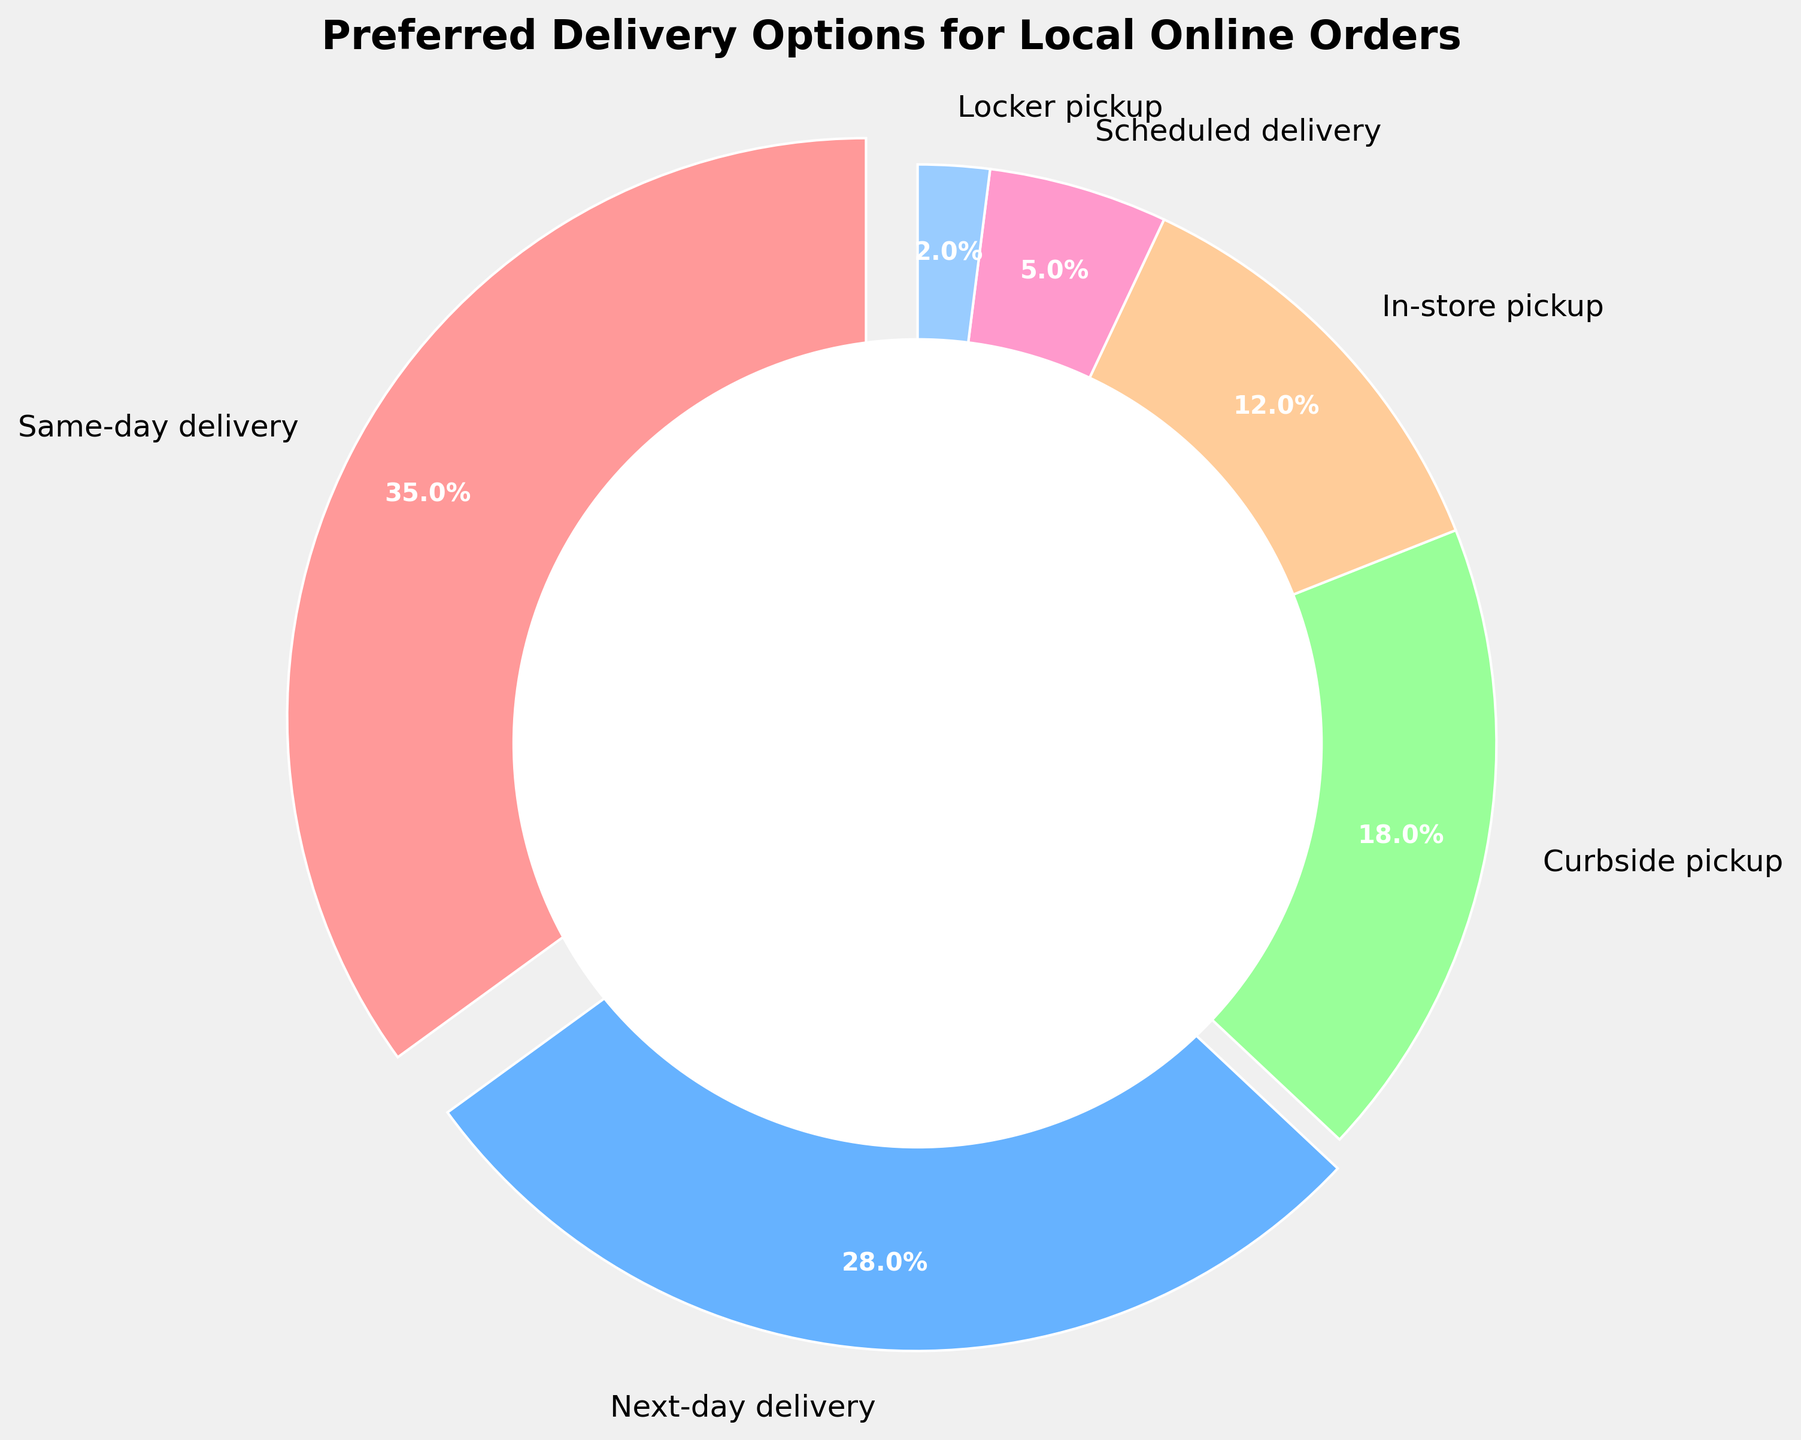what is the most preferred delivery option? The largest segment in the pie chart corresponds to the largest value among the delivery options. Same-day delivery has the largest percentage of 35%.
Answer: Same-day delivery what delivery option has the smallest preference? The smallest segment in the pie chart indicates the least preferred option. Locker pickup has the smallest percentage of 2%.
Answer: Locker pickup which delivery option is preferred more, next-day delivery or in-store pickup? Compare the percentage values of next-day delivery and in-store pickup. Next-day delivery is 28%, and in-store pickup is 12%. 28% is greater than 12%.
Answer: Next-day delivery what is the combined percentage of curbside pickup and locker pickup? Sum the percentages of curbside pickup and locker pickup. Curbside pickup is 18% and locker pickup is 2%, so 18 + 2 = 20%.
Answer: 20% how much more preferred is curbside pickup compared to scheduled delivery? Subtract the percentage of scheduled delivery from curbside pickup. Curbside pickup is 18% and scheduled delivery is 5%, so 18 - 5 = 13%.
Answer: 13% which has a higher preference, scheduled delivery or locker pickup? Compare the percentage values of scheduled delivery and locker pickup. Scheduled delivery is 5% and locker pickup is 2%. 5% is greater than 2%.
Answer: Scheduled delivery what is the total percentage of delivery options that are picked up (either curbside, in-store, or from a locker)? Sum the percentages of curbside pickup, in-store pickup, and locker pickup. Curbside pickup is 18%, in-store pickup is 12%, and locker pickup is 2%, so 18 + 12 + 2 = 32%.
Answer: 32% what proportion of the total percentage is made up by same-day and next-day deliveries combined? Sum the percentages of same-day delivery and next-day delivery and then divide by the total percentage. Same-day delivery is 35% and next-day delivery is 28%, so (35 + 28)/100 = 63%.
Answer: 63% how does the preference for in-store pickup compare to scheduled delivery? Subtract the percentage of scheduled delivery from in-store pickup. In-store pickup is 12% and scheduled delivery is 5%, so 12 - 5 = 7%.
Answer: 7% 